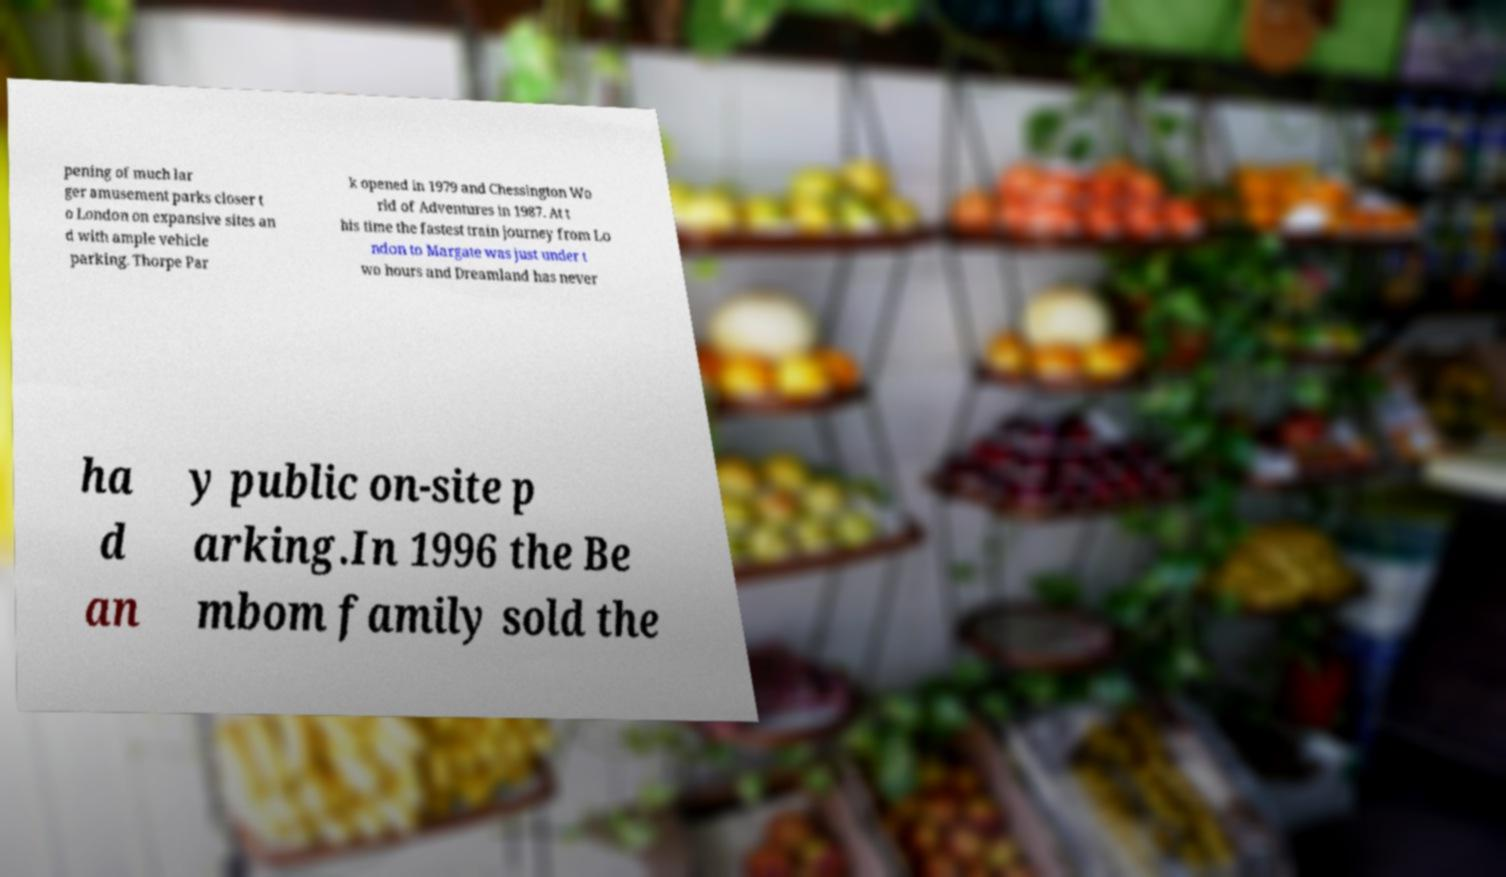What messages or text are displayed in this image? I need them in a readable, typed format. pening of much lar ger amusement parks closer t o London on expansive sites an d with ample vehicle parking. Thorpe Par k opened in 1979 and Chessington Wo rld of Adventures in 1987. At t his time the fastest train journey from Lo ndon to Margate was just under t wo hours and Dreamland has never ha d an y public on-site p arking.In 1996 the Be mbom family sold the 